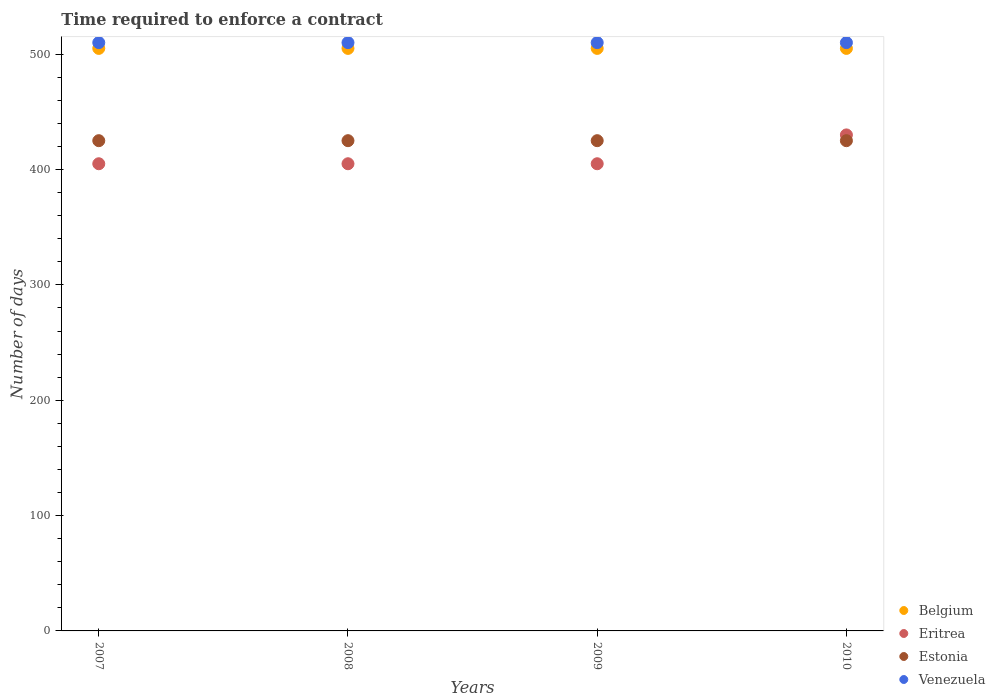How many different coloured dotlines are there?
Give a very brief answer. 4. What is the number of days required to enforce a contract in Estonia in 2007?
Provide a short and direct response. 425. Across all years, what is the maximum number of days required to enforce a contract in Estonia?
Give a very brief answer. 425. Across all years, what is the minimum number of days required to enforce a contract in Belgium?
Ensure brevity in your answer.  505. In which year was the number of days required to enforce a contract in Venezuela minimum?
Provide a short and direct response. 2007. What is the total number of days required to enforce a contract in Venezuela in the graph?
Your answer should be compact. 2040. What is the difference between the number of days required to enforce a contract in Estonia in 2007 and that in 2009?
Offer a very short reply. 0. What is the average number of days required to enforce a contract in Venezuela per year?
Make the answer very short. 510. In the year 2009, what is the difference between the number of days required to enforce a contract in Venezuela and number of days required to enforce a contract in Eritrea?
Ensure brevity in your answer.  105. In how many years, is the number of days required to enforce a contract in Belgium greater than 380 days?
Make the answer very short. 4. What is the ratio of the number of days required to enforce a contract in Eritrea in 2008 to that in 2010?
Offer a terse response. 0.94. Is the number of days required to enforce a contract in Eritrea in 2008 less than that in 2010?
Offer a terse response. Yes. Is the difference between the number of days required to enforce a contract in Venezuela in 2008 and 2009 greater than the difference between the number of days required to enforce a contract in Eritrea in 2008 and 2009?
Keep it short and to the point. No. Is it the case that in every year, the sum of the number of days required to enforce a contract in Belgium and number of days required to enforce a contract in Estonia  is greater than the number of days required to enforce a contract in Venezuela?
Your response must be concise. Yes. Is the number of days required to enforce a contract in Estonia strictly greater than the number of days required to enforce a contract in Belgium over the years?
Your answer should be compact. No. Are the values on the major ticks of Y-axis written in scientific E-notation?
Your answer should be very brief. No. Does the graph contain grids?
Provide a succinct answer. No. How many legend labels are there?
Give a very brief answer. 4. What is the title of the graph?
Give a very brief answer. Time required to enforce a contract. What is the label or title of the Y-axis?
Keep it short and to the point. Number of days. What is the Number of days in Belgium in 2007?
Provide a succinct answer. 505. What is the Number of days of Eritrea in 2007?
Give a very brief answer. 405. What is the Number of days of Estonia in 2007?
Give a very brief answer. 425. What is the Number of days in Venezuela in 2007?
Your answer should be compact. 510. What is the Number of days of Belgium in 2008?
Offer a terse response. 505. What is the Number of days in Eritrea in 2008?
Provide a short and direct response. 405. What is the Number of days in Estonia in 2008?
Your answer should be compact. 425. What is the Number of days of Venezuela in 2008?
Ensure brevity in your answer.  510. What is the Number of days of Belgium in 2009?
Give a very brief answer. 505. What is the Number of days of Eritrea in 2009?
Provide a short and direct response. 405. What is the Number of days in Estonia in 2009?
Keep it short and to the point. 425. What is the Number of days in Venezuela in 2009?
Keep it short and to the point. 510. What is the Number of days in Belgium in 2010?
Provide a short and direct response. 505. What is the Number of days of Eritrea in 2010?
Give a very brief answer. 430. What is the Number of days in Estonia in 2010?
Your answer should be very brief. 425. What is the Number of days in Venezuela in 2010?
Make the answer very short. 510. Across all years, what is the maximum Number of days in Belgium?
Provide a succinct answer. 505. Across all years, what is the maximum Number of days in Eritrea?
Your response must be concise. 430. Across all years, what is the maximum Number of days in Estonia?
Ensure brevity in your answer.  425. Across all years, what is the maximum Number of days of Venezuela?
Provide a short and direct response. 510. Across all years, what is the minimum Number of days of Belgium?
Offer a very short reply. 505. Across all years, what is the minimum Number of days of Eritrea?
Your response must be concise. 405. Across all years, what is the minimum Number of days of Estonia?
Offer a very short reply. 425. Across all years, what is the minimum Number of days in Venezuela?
Give a very brief answer. 510. What is the total Number of days in Belgium in the graph?
Keep it short and to the point. 2020. What is the total Number of days in Eritrea in the graph?
Provide a succinct answer. 1645. What is the total Number of days in Estonia in the graph?
Provide a succinct answer. 1700. What is the total Number of days of Venezuela in the graph?
Offer a terse response. 2040. What is the difference between the Number of days in Eritrea in 2007 and that in 2008?
Give a very brief answer. 0. What is the difference between the Number of days in Estonia in 2007 and that in 2009?
Offer a terse response. 0. What is the difference between the Number of days in Venezuela in 2007 and that in 2009?
Keep it short and to the point. 0. What is the difference between the Number of days in Estonia in 2007 and that in 2010?
Give a very brief answer. 0. What is the difference between the Number of days of Venezuela in 2007 and that in 2010?
Your answer should be very brief. 0. What is the difference between the Number of days in Belgium in 2008 and that in 2009?
Your answer should be compact. 0. What is the difference between the Number of days in Eritrea in 2008 and that in 2010?
Provide a succinct answer. -25. What is the difference between the Number of days of Venezuela in 2008 and that in 2010?
Your response must be concise. 0. What is the difference between the Number of days of Belgium in 2009 and that in 2010?
Offer a terse response. 0. What is the difference between the Number of days in Eritrea in 2009 and that in 2010?
Offer a very short reply. -25. What is the difference between the Number of days of Belgium in 2007 and the Number of days of Estonia in 2008?
Your response must be concise. 80. What is the difference between the Number of days in Eritrea in 2007 and the Number of days in Venezuela in 2008?
Offer a very short reply. -105. What is the difference between the Number of days in Estonia in 2007 and the Number of days in Venezuela in 2008?
Offer a terse response. -85. What is the difference between the Number of days of Eritrea in 2007 and the Number of days of Venezuela in 2009?
Offer a very short reply. -105. What is the difference between the Number of days of Estonia in 2007 and the Number of days of Venezuela in 2009?
Provide a succinct answer. -85. What is the difference between the Number of days in Belgium in 2007 and the Number of days in Eritrea in 2010?
Ensure brevity in your answer.  75. What is the difference between the Number of days in Belgium in 2007 and the Number of days in Estonia in 2010?
Provide a succinct answer. 80. What is the difference between the Number of days of Belgium in 2007 and the Number of days of Venezuela in 2010?
Offer a very short reply. -5. What is the difference between the Number of days in Eritrea in 2007 and the Number of days in Venezuela in 2010?
Offer a very short reply. -105. What is the difference between the Number of days of Estonia in 2007 and the Number of days of Venezuela in 2010?
Keep it short and to the point. -85. What is the difference between the Number of days in Belgium in 2008 and the Number of days in Eritrea in 2009?
Your answer should be very brief. 100. What is the difference between the Number of days of Belgium in 2008 and the Number of days of Venezuela in 2009?
Offer a very short reply. -5. What is the difference between the Number of days of Eritrea in 2008 and the Number of days of Estonia in 2009?
Give a very brief answer. -20. What is the difference between the Number of days of Eritrea in 2008 and the Number of days of Venezuela in 2009?
Provide a short and direct response. -105. What is the difference between the Number of days in Estonia in 2008 and the Number of days in Venezuela in 2009?
Ensure brevity in your answer.  -85. What is the difference between the Number of days in Belgium in 2008 and the Number of days in Eritrea in 2010?
Offer a very short reply. 75. What is the difference between the Number of days of Belgium in 2008 and the Number of days of Venezuela in 2010?
Make the answer very short. -5. What is the difference between the Number of days in Eritrea in 2008 and the Number of days in Venezuela in 2010?
Your answer should be compact. -105. What is the difference between the Number of days of Estonia in 2008 and the Number of days of Venezuela in 2010?
Keep it short and to the point. -85. What is the difference between the Number of days of Eritrea in 2009 and the Number of days of Estonia in 2010?
Your answer should be compact. -20. What is the difference between the Number of days of Eritrea in 2009 and the Number of days of Venezuela in 2010?
Provide a succinct answer. -105. What is the difference between the Number of days in Estonia in 2009 and the Number of days in Venezuela in 2010?
Keep it short and to the point. -85. What is the average Number of days of Belgium per year?
Provide a succinct answer. 505. What is the average Number of days in Eritrea per year?
Offer a terse response. 411.25. What is the average Number of days of Estonia per year?
Provide a short and direct response. 425. What is the average Number of days in Venezuela per year?
Keep it short and to the point. 510. In the year 2007, what is the difference between the Number of days in Eritrea and Number of days in Venezuela?
Provide a succinct answer. -105. In the year 2007, what is the difference between the Number of days in Estonia and Number of days in Venezuela?
Your response must be concise. -85. In the year 2008, what is the difference between the Number of days in Belgium and Number of days in Eritrea?
Your answer should be compact. 100. In the year 2008, what is the difference between the Number of days of Belgium and Number of days of Estonia?
Give a very brief answer. 80. In the year 2008, what is the difference between the Number of days in Belgium and Number of days in Venezuela?
Provide a short and direct response. -5. In the year 2008, what is the difference between the Number of days of Eritrea and Number of days of Estonia?
Offer a very short reply. -20. In the year 2008, what is the difference between the Number of days in Eritrea and Number of days in Venezuela?
Your answer should be compact. -105. In the year 2008, what is the difference between the Number of days of Estonia and Number of days of Venezuela?
Your response must be concise. -85. In the year 2009, what is the difference between the Number of days of Eritrea and Number of days of Estonia?
Your response must be concise. -20. In the year 2009, what is the difference between the Number of days in Eritrea and Number of days in Venezuela?
Keep it short and to the point. -105. In the year 2009, what is the difference between the Number of days in Estonia and Number of days in Venezuela?
Provide a short and direct response. -85. In the year 2010, what is the difference between the Number of days of Belgium and Number of days of Eritrea?
Keep it short and to the point. 75. In the year 2010, what is the difference between the Number of days of Belgium and Number of days of Venezuela?
Provide a succinct answer. -5. In the year 2010, what is the difference between the Number of days of Eritrea and Number of days of Estonia?
Give a very brief answer. 5. In the year 2010, what is the difference between the Number of days of Eritrea and Number of days of Venezuela?
Keep it short and to the point. -80. In the year 2010, what is the difference between the Number of days of Estonia and Number of days of Venezuela?
Provide a succinct answer. -85. What is the ratio of the Number of days of Belgium in 2007 to that in 2008?
Give a very brief answer. 1. What is the ratio of the Number of days in Estonia in 2007 to that in 2008?
Provide a short and direct response. 1. What is the ratio of the Number of days of Belgium in 2007 to that in 2010?
Make the answer very short. 1. What is the ratio of the Number of days in Eritrea in 2007 to that in 2010?
Offer a terse response. 0.94. What is the ratio of the Number of days in Belgium in 2008 to that in 2009?
Your response must be concise. 1. What is the ratio of the Number of days of Estonia in 2008 to that in 2009?
Provide a succinct answer. 1. What is the ratio of the Number of days in Eritrea in 2008 to that in 2010?
Your answer should be very brief. 0.94. What is the ratio of the Number of days of Belgium in 2009 to that in 2010?
Provide a succinct answer. 1. What is the ratio of the Number of days in Eritrea in 2009 to that in 2010?
Give a very brief answer. 0.94. What is the ratio of the Number of days of Estonia in 2009 to that in 2010?
Offer a very short reply. 1. What is the ratio of the Number of days in Venezuela in 2009 to that in 2010?
Make the answer very short. 1. What is the difference between the highest and the second highest Number of days in Belgium?
Ensure brevity in your answer.  0. What is the difference between the highest and the second highest Number of days in Estonia?
Make the answer very short. 0. What is the difference between the highest and the second highest Number of days in Venezuela?
Offer a terse response. 0. What is the difference between the highest and the lowest Number of days of Venezuela?
Ensure brevity in your answer.  0. 